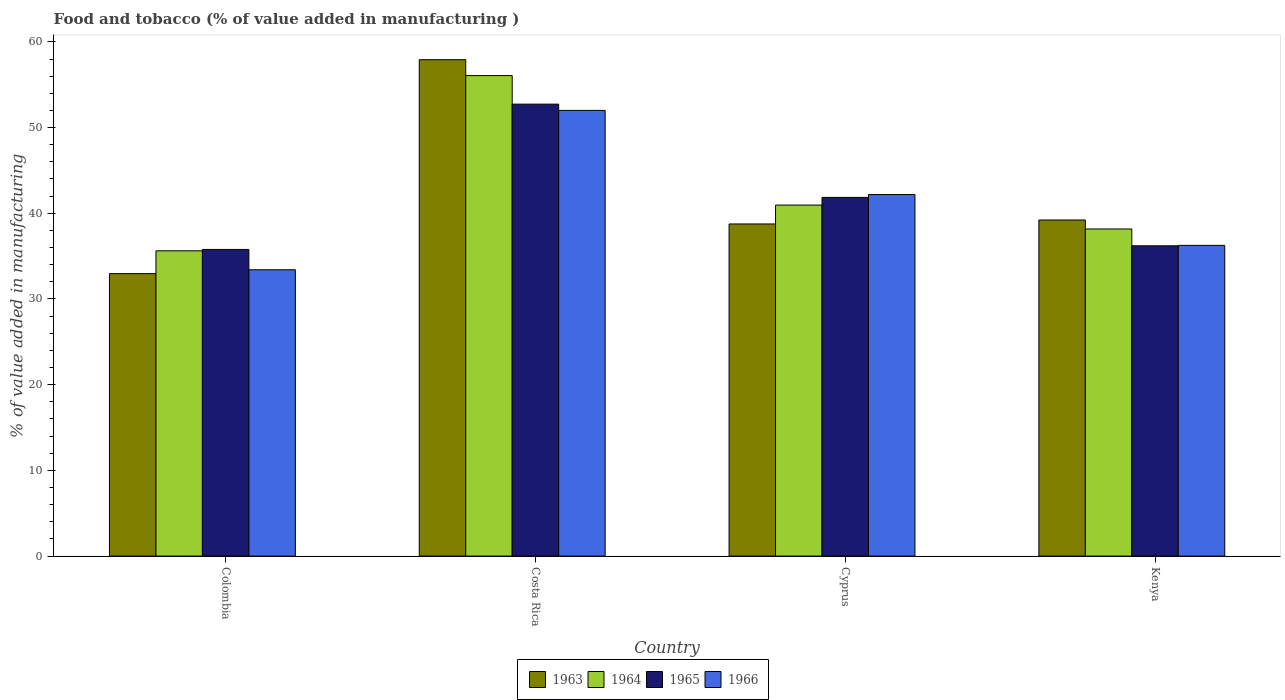How many groups of bars are there?
Offer a very short reply. 4. How many bars are there on the 4th tick from the left?
Offer a terse response. 4. What is the label of the 3rd group of bars from the left?
Your response must be concise. Cyprus. What is the value added in manufacturing food and tobacco in 1966 in Costa Rica?
Provide a succinct answer. 52. Across all countries, what is the maximum value added in manufacturing food and tobacco in 1964?
Offer a very short reply. 56.07. Across all countries, what is the minimum value added in manufacturing food and tobacco in 1963?
Give a very brief answer. 32.96. In which country was the value added in manufacturing food and tobacco in 1963 maximum?
Offer a very short reply. Costa Rica. In which country was the value added in manufacturing food and tobacco in 1964 minimum?
Provide a succinct answer. Colombia. What is the total value added in manufacturing food and tobacco in 1963 in the graph?
Your response must be concise. 168.85. What is the difference between the value added in manufacturing food and tobacco in 1965 in Costa Rica and that in Kenya?
Make the answer very short. 16.53. What is the difference between the value added in manufacturing food and tobacco in 1965 in Kenya and the value added in manufacturing food and tobacco in 1964 in Costa Rica?
Make the answer very short. -19.86. What is the average value added in manufacturing food and tobacco in 1964 per country?
Make the answer very short. 42.7. What is the difference between the value added in manufacturing food and tobacco of/in 1966 and value added in manufacturing food and tobacco of/in 1963 in Cyprus?
Provide a short and direct response. 3.43. What is the ratio of the value added in manufacturing food and tobacco in 1964 in Cyprus to that in Kenya?
Offer a very short reply. 1.07. Is the value added in manufacturing food and tobacco in 1965 in Colombia less than that in Cyprus?
Provide a short and direct response. Yes. What is the difference between the highest and the second highest value added in manufacturing food and tobacco in 1963?
Give a very brief answer. 19.17. What is the difference between the highest and the lowest value added in manufacturing food and tobacco in 1964?
Offer a terse response. 20.45. In how many countries, is the value added in manufacturing food and tobacco in 1966 greater than the average value added in manufacturing food and tobacco in 1966 taken over all countries?
Make the answer very short. 2. Is the sum of the value added in manufacturing food and tobacco in 1964 in Colombia and Costa Rica greater than the maximum value added in manufacturing food and tobacco in 1963 across all countries?
Ensure brevity in your answer.  Yes. Is it the case that in every country, the sum of the value added in manufacturing food and tobacco in 1966 and value added in manufacturing food and tobacco in 1964 is greater than the sum of value added in manufacturing food and tobacco in 1965 and value added in manufacturing food and tobacco in 1963?
Provide a succinct answer. No. What does the 2nd bar from the left in Cyprus represents?
Keep it short and to the point. 1964. What does the 1st bar from the right in Kenya represents?
Ensure brevity in your answer.  1966. Is it the case that in every country, the sum of the value added in manufacturing food and tobacco in 1965 and value added in manufacturing food and tobacco in 1964 is greater than the value added in manufacturing food and tobacco in 1966?
Your response must be concise. Yes. How many bars are there?
Ensure brevity in your answer.  16. Are all the bars in the graph horizontal?
Give a very brief answer. No. Does the graph contain grids?
Provide a short and direct response. No. Where does the legend appear in the graph?
Offer a terse response. Bottom center. How are the legend labels stacked?
Keep it short and to the point. Horizontal. What is the title of the graph?
Give a very brief answer. Food and tobacco (% of value added in manufacturing ). What is the label or title of the Y-axis?
Your response must be concise. % of value added in manufacturing. What is the % of value added in manufacturing in 1963 in Colombia?
Provide a succinct answer. 32.96. What is the % of value added in manufacturing of 1964 in Colombia?
Your response must be concise. 35.62. What is the % of value added in manufacturing in 1965 in Colombia?
Offer a very short reply. 35.78. What is the % of value added in manufacturing of 1966 in Colombia?
Your answer should be compact. 33.41. What is the % of value added in manufacturing in 1963 in Costa Rica?
Offer a terse response. 57.92. What is the % of value added in manufacturing of 1964 in Costa Rica?
Provide a succinct answer. 56.07. What is the % of value added in manufacturing in 1965 in Costa Rica?
Provide a short and direct response. 52.73. What is the % of value added in manufacturing of 1966 in Costa Rica?
Offer a terse response. 52. What is the % of value added in manufacturing of 1963 in Cyprus?
Your answer should be compact. 38.75. What is the % of value added in manufacturing in 1964 in Cyprus?
Provide a succinct answer. 40.96. What is the % of value added in manufacturing in 1965 in Cyprus?
Offer a terse response. 41.85. What is the % of value added in manufacturing of 1966 in Cyprus?
Give a very brief answer. 42.19. What is the % of value added in manufacturing in 1963 in Kenya?
Ensure brevity in your answer.  39.22. What is the % of value added in manufacturing in 1964 in Kenya?
Provide a succinct answer. 38.17. What is the % of value added in manufacturing in 1965 in Kenya?
Your answer should be very brief. 36.2. What is the % of value added in manufacturing of 1966 in Kenya?
Your answer should be very brief. 36.25. Across all countries, what is the maximum % of value added in manufacturing of 1963?
Your answer should be compact. 57.92. Across all countries, what is the maximum % of value added in manufacturing of 1964?
Your response must be concise. 56.07. Across all countries, what is the maximum % of value added in manufacturing of 1965?
Ensure brevity in your answer.  52.73. Across all countries, what is the maximum % of value added in manufacturing of 1966?
Keep it short and to the point. 52. Across all countries, what is the minimum % of value added in manufacturing in 1963?
Your answer should be compact. 32.96. Across all countries, what is the minimum % of value added in manufacturing in 1964?
Your answer should be compact. 35.62. Across all countries, what is the minimum % of value added in manufacturing of 1965?
Your answer should be compact. 35.78. Across all countries, what is the minimum % of value added in manufacturing of 1966?
Ensure brevity in your answer.  33.41. What is the total % of value added in manufacturing of 1963 in the graph?
Offer a terse response. 168.85. What is the total % of value added in manufacturing of 1964 in the graph?
Make the answer very short. 170.81. What is the total % of value added in manufacturing of 1965 in the graph?
Keep it short and to the point. 166.57. What is the total % of value added in manufacturing of 1966 in the graph?
Your answer should be compact. 163.86. What is the difference between the % of value added in manufacturing in 1963 in Colombia and that in Costa Rica?
Keep it short and to the point. -24.96. What is the difference between the % of value added in manufacturing in 1964 in Colombia and that in Costa Rica?
Offer a terse response. -20.45. What is the difference between the % of value added in manufacturing of 1965 in Colombia and that in Costa Rica?
Your response must be concise. -16.95. What is the difference between the % of value added in manufacturing of 1966 in Colombia and that in Costa Rica?
Offer a very short reply. -18.59. What is the difference between the % of value added in manufacturing of 1963 in Colombia and that in Cyprus?
Provide a short and direct response. -5.79. What is the difference between the % of value added in manufacturing of 1964 in Colombia and that in Cyprus?
Make the answer very short. -5.34. What is the difference between the % of value added in manufacturing in 1965 in Colombia and that in Cyprus?
Provide a short and direct response. -6.07. What is the difference between the % of value added in manufacturing of 1966 in Colombia and that in Cyprus?
Your response must be concise. -8.78. What is the difference between the % of value added in manufacturing of 1963 in Colombia and that in Kenya?
Your answer should be very brief. -6.26. What is the difference between the % of value added in manufacturing of 1964 in Colombia and that in Kenya?
Your answer should be compact. -2.55. What is the difference between the % of value added in manufacturing of 1965 in Colombia and that in Kenya?
Ensure brevity in your answer.  -0.42. What is the difference between the % of value added in manufacturing in 1966 in Colombia and that in Kenya?
Offer a very short reply. -2.84. What is the difference between the % of value added in manufacturing of 1963 in Costa Rica and that in Cyprus?
Offer a very short reply. 19.17. What is the difference between the % of value added in manufacturing of 1964 in Costa Rica and that in Cyprus?
Your response must be concise. 15.11. What is the difference between the % of value added in manufacturing in 1965 in Costa Rica and that in Cyprus?
Ensure brevity in your answer.  10.88. What is the difference between the % of value added in manufacturing in 1966 in Costa Rica and that in Cyprus?
Provide a succinct answer. 9.82. What is the difference between the % of value added in manufacturing of 1963 in Costa Rica and that in Kenya?
Your answer should be compact. 18.7. What is the difference between the % of value added in manufacturing of 1964 in Costa Rica and that in Kenya?
Your answer should be very brief. 17.9. What is the difference between the % of value added in manufacturing of 1965 in Costa Rica and that in Kenya?
Make the answer very short. 16.53. What is the difference between the % of value added in manufacturing in 1966 in Costa Rica and that in Kenya?
Your response must be concise. 15.75. What is the difference between the % of value added in manufacturing of 1963 in Cyprus and that in Kenya?
Keep it short and to the point. -0.46. What is the difference between the % of value added in manufacturing of 1964 in Cyprus and that in Kenya?
Your response must be concise. 2.79. What is the difference between the % of value added in manufacturing in 1965 in Cyprus and that in Kenya?
Provide a succinct answer. 5.65. What is the difference between the % of value added in manufacturing in 1966 in Cyprus and that in Kenya?
Your answer should be very brief. 5.93. What is the difference between the % of value added in manufacturing in 1963 in Colombia and the % of value added in manufacturing in 1964 in Costa Rica?
Ensure brevity in your answer.  -23.11. What is the difference between the % of value added in manufacturing of 1963 in Colombia and the % of value added in manufacturing of 1965 in Costa Rica?
Make the answer very short. -19.77. What is the difference between the % of value added in manufacturing in 1963 in Colombia and the % of value added in manufacturing in 1966 in Costa Rica?
Your response must be concise. -19.04. What is the difference between the % of value added in manufacturing of 1964 in Colombia and the % of value added in manufacturing of 1965 in Costa Rica?
Make the answer very short. -17.11. What is the difference between the % of value added in manufacturing of 1964 in Colombia and the % of value added in manufacturing of 1966 in Costa Rica?
Your answer should be very brief. -16.38. What is the difference between the % of value added in manufacturing in 1965 in Colombia and the % of value added in manufacturing in 1966 in Costa Rica?
Offer a very short reply. -16.22. What is the difference between the % of value added in manufacturing of 1963 in Colombia and the % of value added in manufacturing of 1964 in Cyprus?
Your answer should be very brief. -8. What is the difference between the % of value added in manufacturing in 1963 in Colombia and the % of value added in manufacturing in 1965 in Cyprus?
Offer a very short reply. -8.89. What is the difference between the % of value added in manufacturing in 1963 in Colombia and the % of value added in manufacturing in 1966 in Cyprus?
Provide a succinct answer. -9.23. What is the difference between the % of value added in manufacturing of 1964 in Colombia and the % of value added in manufacturing of 1965 in Cyprus?
Your answer should be compact. -6.23. What is the difference between the % of value added in manufacturing of 1964 in Colombia and the % of value added in manufacturing of 1966 in Cyprus?
Offer a very short reply. -6.57. What is the difference between the % of value added in manufacturing of 1965 in Colombia and the % of value added in manufacturing of 1966 in Cyprus?
Provide a succinct answer. -6.41. What is the difference between the % of value added in manufacturing in 1963 in Colombia and the % of value added in manufacturing in 1964 in Kenya?
Offer a very short reply. -5.21. What is the difference between the % of value added in manufacturing in 1963 in Colombia and the % of value added in manufacturing in 1965 in Kenya?
Make the answer very short. -3.24. What is the difference between the % of value added in manufacturing in 1963 in Colombia and the % of value added in manufacturing in 1966 in Kenya?
Keep it short and to the point. -3.29. What is the difference between the % of value added in manufacturing of 1964 in Colombia and the % of value added in manufacturing of 1965 in Kenya?
Offer a terse response. -0.58. What is the difference between the % of value added in manufacturing in 1964 in Colombia and the % of value added in manufacturing in 1966 in Kenya?
Give a very brief answer. -0.63. What is the difference between the % of value added in manufacturing of 1965 in Colombia and the % of value added in manufacturing of 1966 in Kenya?
Provide a succinct answer. -0.47. What is the difference between the % of value added in manufacturing of 1963 in Costa Rica and the % of value added in manufacturing of 1964 in Cyprus?
Your response must be concise. 16.96. What is the difference between the % of value added in manufacturing of 1963 in Costa Rica and the % of value added in manufacturing of 1965 in Cyprus?
Give a very brief answer. 16.07. What is the difference between the % of value added in manufacturing of 1963 in Costa Rica and the % of value added in manufacturing of 1966 in Cyprus?
Your answer should be compact. 15.73. What is the difference between the % of value added in manufacturing in 1964 in Costa Rica and the % of value added in manufacturing in 1965 in Cyprus?
Offer a terse response. 14.21. What is the difference between the % of value added in manufacturing of 1964 in Costa Rica and the % of value added in manufacturing of 1966 in Cyprus?
Make the answer very short. 13.88. What is the difference between the % of value added in manufacturing in 1965 in Costa Rica and the % of value added in manufacturing in 1966 in Cyprus?
Ensure brevity in your answer.  10.55. What is the difference between the % of value added in manufacturing of 1963 in Costa Rica and the % of value added in manufacturing of 1964 in Kenya?
Make the answer very short. 19.75. What is the difference between the % of value added in manufacturing of 1963 in Costa Rica and the % of value added in manufacturing of 1965 in Kenya?
Your answer should be very brief. 21.72. What is the difference between the % of value added in manufacturing in 1963 in Costa Rica and the % of value added in manufacturing in 1966 in Kenya?
Offer a terse response. 21.67. What is the difference between the % of value added in manufacturing in 1964 in Costa Rica and the % of value added in manufacturing in 1965 in Kenya?
Offer a very short reply. 19.86. What is the difference between the % of value added in manufacturing in 1964 in Costa Rica and the % of value added in manufacturing in 1966 in Kenya?
Make the answer very short. 19.81. What is the difference between the % of value added in manufacturing of 1965 in Costa Rica and the % of value added in manufacturing of 1966 in Kenya?
Offer a very short reply. 16.48. What is the difference between the % of value added in manufacturing in 1963 in Cyprus and the % of value added in manufacturing in 1964 in Kenya?
Provide a short and direct response. 0.59. What is the difference between the % of value added in manufacturing in 1963 in Cyprus and the % of value added in manufacturing in 1965 in Kenya?
Provide a succinct answer. 2.55. What is the difference between the % of value added in manufacturing in 1963 in Cyprus and the % of value added in manufacturing in 1966 in Kenya?
Offer a very short reply. 2.5. What is the difference between the % of value added in manufacturing in 1964 in Cyprus and the % of value added in manufacturing in 1965 in Kenya?
Offer a terse response. 4.75. What is the difference between the % of value added in manufacturing of 1964 in Cyprus and the % of value added in manufacturing of 1966 in Kenya?
Give a very brief answer. 4.7. What is the difference between the % of value added in manufacturing of 1965 in Cyprus and the % of value added in manufacturing of 1966 in Kenya?
Your answer should be compact. 5.6. What is the average % of value added in manufacturing in 1963 per country?
Offer a terse response. 42.21. What is the average % of value added in manufacturing in 1964 per country?
Ensure brevity in your answer.  42.7. What is the average % of value added in manufacturing of 1965 per country?
Your answer should be very brief. 41.64. What is the average % of value added in manufacturing in 1966 per country?
Keep it short and to the point. 40.96. What is the difference between the % of value added in manufacturing of 1963 and % of value added in manufacturing of 1964 in Colombia?
Keep it short and to the point. -2.66. What is the difference between the % of value added in manufacturing of 1963 and % of value added in manufacturing of 1965 in Colombia?
Keep it short and to the point. -2.82. What is the difference between the % of value added in manufacturing in 1963 and % of value added in manufacturing in 1966 in Colombia?
Provide a short and direct response. -0.45. What is the difference between the % of value added in manufacturing of 1964 and % of value added in manufacturing of 1965 in Colombia?
Keep it short and to the point. -0.16. What is the difference between the % of value added in manufacturing of 1964 and % of value added in manufacturing of 1966 in Colombia?
Keep it short and to the point. 2.21. What is the difference between the % of value added in manufacturing in 1965 and % of value added in manufacturing in 1966 in Colombia?
Your response must be concise. 2.37. What is the difference between the % of value added in manufacturing of 1963 and % of value added in manufacturing of 1964 in Costa Rica?
Your answer should be compact. 1.85. What is the difference between the % of value added in manufacturing in 1963 and % of value added in manufacturing in 1965 in Costa Rica?
Give a very brief answer. 5.19. What is the difference between the % of value added in manufacturing of 1963 and % of value added in manufacturing of 1966 in Costa Rica?
Provide a short and direct response. 5.92. What is the difference between the % of value added in manufacturing of 1964 and % of value added in manufacturing of 1965 in Costa Rica?
Provide a short and direct response. 3.33. What is the difference between the % of value added in manufacturing of 1964 and % of value added in manufacturing of 1966 in Costa Rica?
Provide a short and direct response. 4.06. What is the difference between the % of value added in manufacturing in 1965 and % of value added in manufacturing in 1966 in Costa Rica?
Give a very brief answer. 0.73. What is the difference between the % of value added in manufacturing of 1963 and % of value added in manufacturing of 1964 in Cyprus?
Your response must be concise. -2.2. What is the difference between the % of value added in manufacturing of 1963 and % of value added in manufacturing of 1965 in Cyprus?
Provide a succinct answer. -3.1. What is the difference between the % of value added in manufacturing of 1963 and % of value added in manufacturing of 1966 in Cyprus?
Ensure brevity in your answer.  -3.43. What is the difference between the % of value added in manufacturing in 1964 and % of value added in manufacturing in 1965 in Cyprus?
Your answer should be compact. -0.9. What is the difference between the % of value added in manufacturing of 1964 and % of value added in manufacturing of 1966 in Cyprus?
Make the answer very short. -1.23. What is the difference between the % of value added in manufacturing in 1965 and % of value added in manufacturing in 1966 in Cyprus?
Your answer should be very brief. -0.33. What is the difference between the % of value added in manufacturing of 1963 and % of value added in manufacturing of 1964 in Kenya?
Provide a short and direct response. 1.05. What is the difference between the % of value added in manufacturing in 1963 and % of value added in manufacturing in 1965 in Kenya?
Make the answer very short. 3.01. What is the difference between the % of value added in manufacturing in 1963 and % of value added in manufacturing in 1966 in Kenya?
Provide a short and direct response. 2.96. What is the difference between the % of value added in manufacturing in 1964 and % of value added in manufacturing in 1965 in Kenya?
Keep it short and to the point. 1.96. What is the difference between the % of value added in manufacturing in 1964 and % of value added in manufacturing in 1966 in Kenya?
Offer a terse response. 1.91. What is the difference between the % of value added in manufacturing in 1965 and % of value added in manufacturing in 1966 in Kenya?
Your response must be concise. -0.05. What is the ratio of the % of value added in manufacturing in 1963 in Colombia to that in Costa Rica?
Offer a terse response. 0.57. What is the ratio of the % of value added in manufacturing of 1964 in Colombia to that in Costa Rica?
Your answer should be compact. 0.64. What is the ratio of the % of value added in manufacturing of 1965 in Colombia to that in Costa Rica?
Offer a very short reply. 0.68. What is the ratio of the % of value added in manufacturing of 1966 in Colombia to that in Costa Rica?
Provide a succinct answer. 0.64. What is the ratio of the % of value added in manufacturing in 1963 in Colombia to that in Cyprus?
Your response must be concise. 0.85. What is the ratio of the % of value added in manufacturing of 1964 in Colombia to that in Cyprus?
Offer a terse response. 0.87. What is the ratio of the % of value added in manufacturing of 1965 in Colombia to that in Cyprus?
Your response must be concise. 0.85. What is the ratio of the % of value added in manufacturing in 1966 in Colombia to that in Cyprus?
Keep it short and to the point. 0.79. What is the ratio of the % of value added in manufacturing in 1963 in Colombia to that in Kenya?
Provide a succinct answer. 0.84. What is the ratio of the % of value added in manufacturing of 1964 in Colombia to that in Kenya?
Ensure brevity in your answer.  0.93. What is the ratio of the % of value added in manufacturing in 1965 in Colombia to that in Kenya?
Provide a short and direct response. 0.99. What is the ratio of the % of value added in manufacturing in 1966 in Colombia to that in Kenya?
Keep it short and to the point. 0.92. What is the ratio of the % of value added in manufacturing of 1963 in Costa Rica to that in Cyprus?
Offer a terse response. 1.49. What is the ratio of the % of value added in manufacturing in 1964 in Costa Rica to that in Cyprus?
Ensure brevity in your answer.  1.37. What is the ratio of the % of value added in manufacturing in 1965 in Costa Rica to that in Cyprus?
Offer a very short reply. 1.26. What is the ratio of the % of value added in manufacturing in 1966 in Costa Rica to that in Cyprus?
Make the answer very short. 1.23. What is the ratio of the % of value added in manufacturing of 1963 in Costa Rica to that in Kenya?
Your response must be concise. 1.48. What is the ratio of the % of value added in manufacturing of 1964 in Costa Rica to that in Kenya?
Your answer should be compact. 1.47. What is the ratio of the % of value added in manufacturing in 1965 in Costa Rica to that in Kenya?
Ensure brevity in your answer.  1.46. What is the ratio of the % of value added in manufacturing of 1966 in Costa Rica to that in Kenya?
Give a very brief answer. 1.43. What is the ratio of the % of value added in manufacturing in 1963 in Cyprus to that in Kenya?
Offer a very short reply. 0.99. What is the ratio of the % of value added in manufacturing of 1964 in Cyprus to that in Kenya?
Keep it short and to the point. 1.07. What is the ratio of the % of value added in manufacturing in 1965 in Cyprus to that in Kenya?
Give a very brief answer. 1.16. What is the ratio of the % of value added in manufacturing of 1966 in Cyprus to that in Kenya?
Offer a terse response. 1.16. What is the difference between the highest and the second highest % of value added in manufacturing in 1963?
Provide a succinct answer. 18.7. What is the difference between the highest and the second highest % of value added in manufacturing of 1964?
Give a very brief answer. 15.11. What is the difference between the highest and the second highest % of value added in manufacturing in 1965?
Offer a very short reply. 10.88. What is the difference between the highest and the second highest % of value added in manufacturing of 1966?
Provide a succinct answer. 9.82. What is the difference between the highest and the lowest % of value added in manufacturing in 1963?
Keep it short and to the point. 24.96. What is the difference between the highest and the lowest % of value added in manufacturing in 1964?
Provide a short and direct response. 20.45. What is the difference between the highest and the lowest % of value added in manufacturing of 1965?
Offer a terse response. 16.95. What is the difference between the highest and the lowest % of value added in manufacturing in 1966?
Provide a short and direct response. 18.59. 